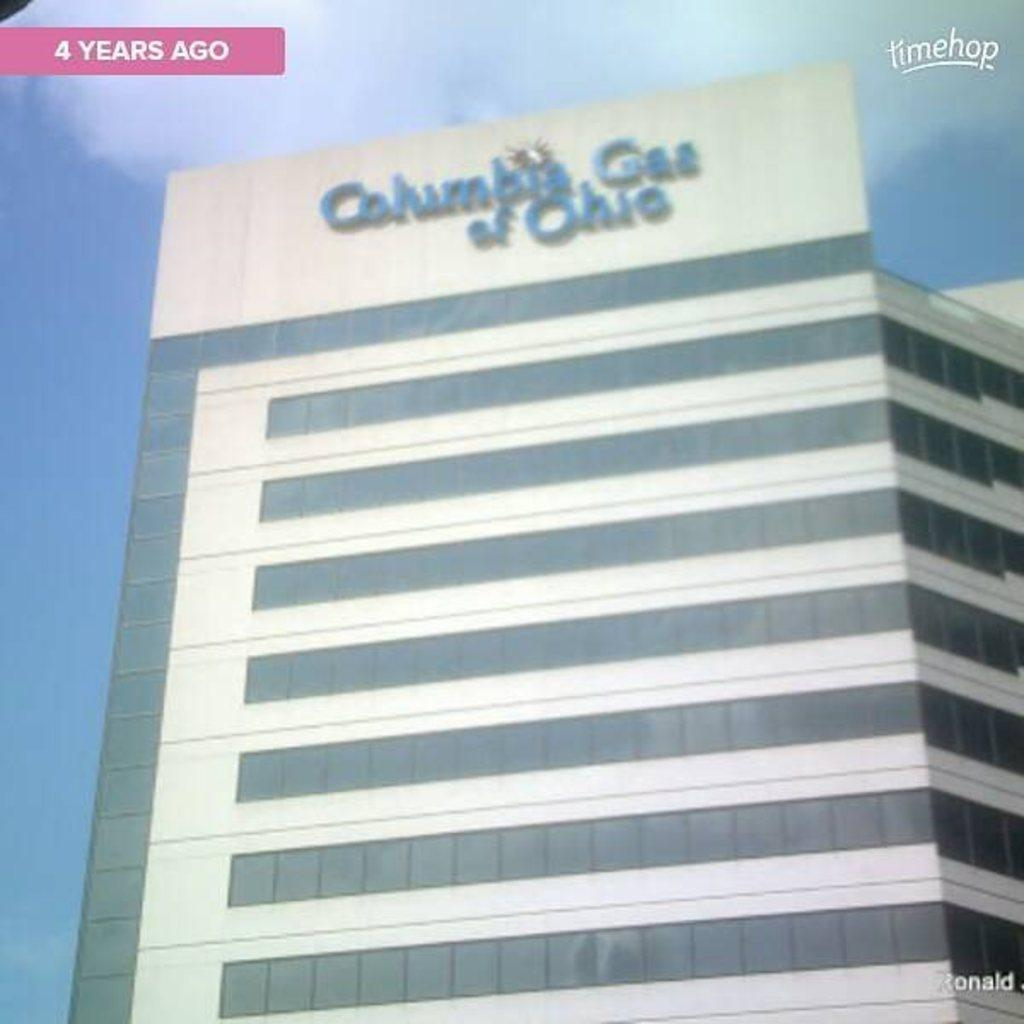What type of structure is present in the image? There is a building in the image. What else can be seen in the image besides the building? There is text and a board visible in the image. What is visible in the background of the image? The sky is visible in the image. Can you tell if the image has been altered in any way? Yes, the image appears to be an edited photo. Where is the vase located in the image? There is no vase present in the image. What type of tax is being discussed in the text of the image? There is no text discussing any type of tax in the image. 